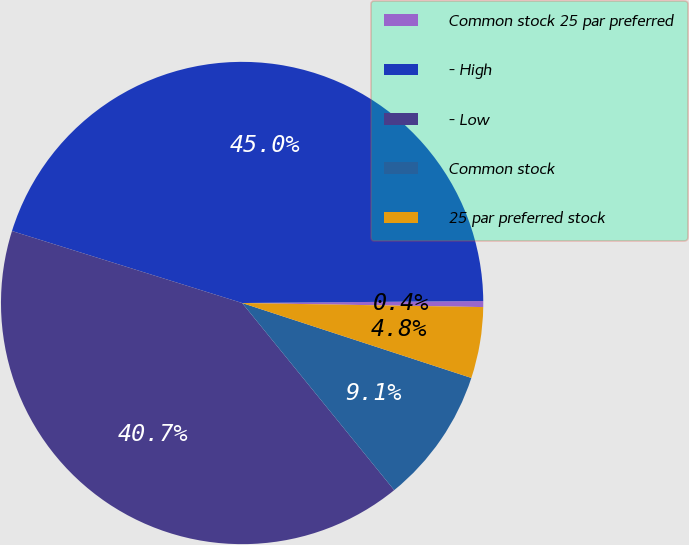<chart> <loc_0><loc_0><loc_500><loc_500><pie_chart><fcel>Common stock 25 par preferred<fcel>- High<fcel>- Low<fcel>Common stock<fcel>25 par preferred stock<nl><fcel>0.4%<fcel>45.04%<fcel>40.68%<fcel>9.11%<fcel>4.76%<nl></chart> 